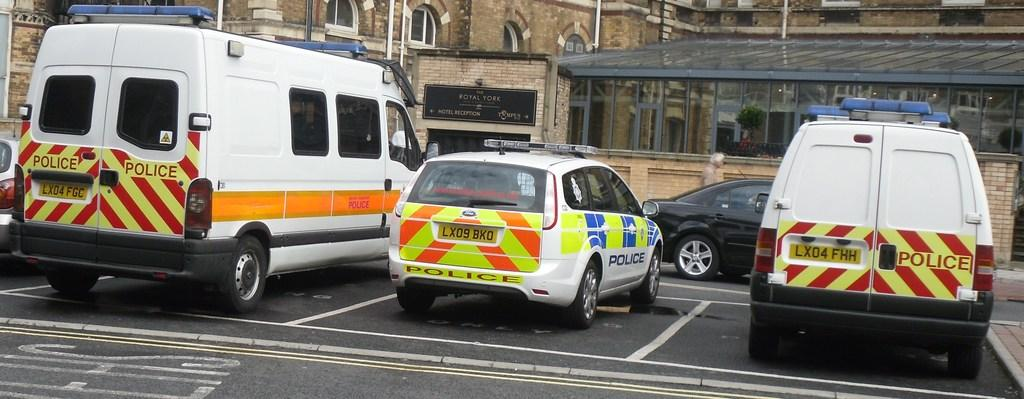What types of objects can be seen in the image? There are vehicles and a building in the image. Can you describe the structure in the image? There is a building in the image, and it has a wall and windows. What material is used for the windows? There is glass in the image, which is used for the windows. What can be seen through the glass? Plants are visible through the glass. What type of brake system is installed on the trucks in the image? There are no trucks present in the image, so it is not possible to determine the type of brake system installed on them. 